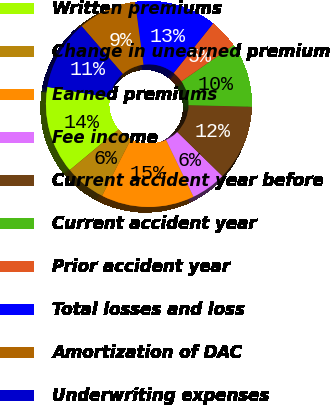Convert chart. <chart><loc_0><loc_0><loc_500><loc_500><pie_chart><fcel>Written premiums<fcel>Change in unearned premium<fcel>Earned premiums<fcel>Fee income<fcel>Current accident year before<fcel>Current accident year<fcel>Prior accident year<fcel>Total losses and loss<fcel>Amortization of DAC<fcel>Underwriting expenses<nl><fcel>13.75%<fcel>6.43%<fcel>14.67%<fcel>5.51%<fcel>11.92%<fcel>10.09%<fcel>4.6%<fcel>12.84%<fcel>9.18%<fcel>11.01%<nl></chart> 